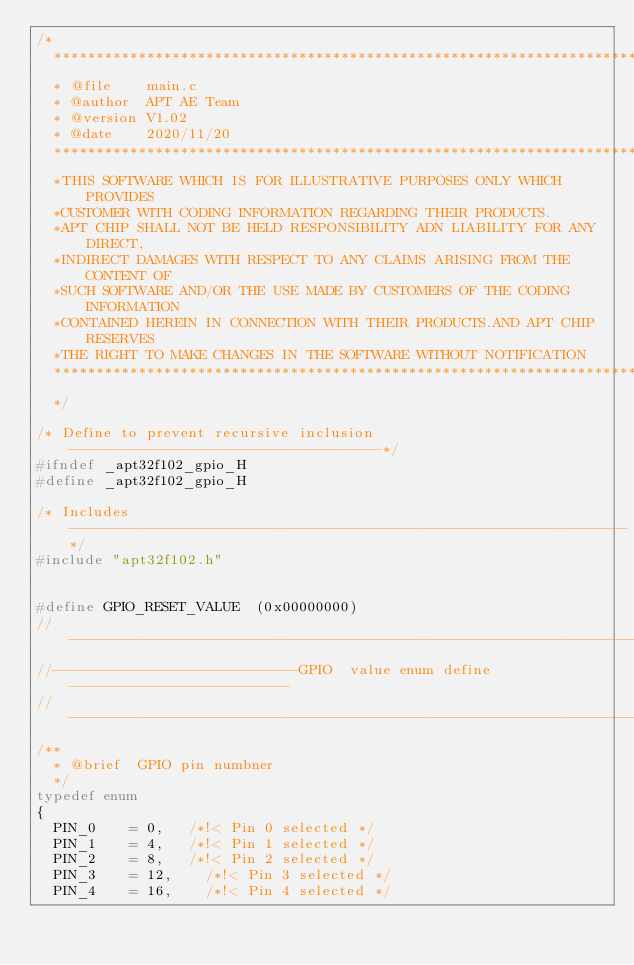<code> <loc_0><loc_0><loc_500><loc_500><_C_>/*
  ******************************************************************************
  * @file    main.c
  * @author  APT AE Team
  * @version V1.02
  * @date    2020/11/20
  ******************************************************************************
  *THIS SOFTWARE WHICH IS FOR ILLUSTRATIVE PURPOSES ONLY WHICH PROVIDES 
  *CUSTOMER WITH CODING INFORMATION REGARDING THEIR PRODUCTS.
  *APT CHIP SHALL NOT BE HELD RESPONSIBILITY ADN LIABILITY FOR ANY DIRECT, 
  *INDIRECT DAMAGES WITH RESPECT TO ANY CLAIMS ARISING FROM THE CONTENT OF 
  *SUCH SOFTWARE AND/OR THE USE MADE BY CUSTOMERS OF THE CODING INFORMATION 
  *CONTAINED HEREIN IN CONNECTION WITH THEIR PRODUCTS.AND APT CHIP RESERVES 
  *THE RIGHT TO MAKE CHANGES IN THE SOFTWARE WITHOUT NOTIFICATION
  ******************************************************************************
  */
 
/* Define to prevent recursive inclusion -------------------------------------*/
#ifndef _apt32f102_gpio_H
#define _apt32f102_gpio_H

/* Includes ------------------------------------------------------------------*/
#include "apt32f102.h"


#define GPIO_RESET_VALUE  (0x00000000)
//--------------------------------------------------------------------------------
//-----------------------------GPIO  value enum define--------------------------
//--------------------------------------------------------------------------------
/**
  * @brief  GPIO pin numbner
  */
typedef enum
{
  PIN_0    = 0,  	/*!< Pin 0 selected */
  PIN_1    = 4,  	/*!< Pin 1 selected */
  PIN_2    = 8,  	/*!< Pin 2 selected */
  PIN_3    = 12,   	/*!< Pin 3 selected */
  PIN_4    = 16,  	/*!< Pin 4 selected */</code> 